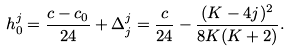<formula> <loc_0><loc_0><loc_500><loc_500>h _ { 0 } ^ { j } = \frac { c - c _ { 0 } } { 2 4 } + \Delta _ { j } ^ { j } = \frac { c } { 2 4 } - \frac { ( K - 4 j ) ^ { 2 } } { 8 K ( K + 2 ) } .</formula> 